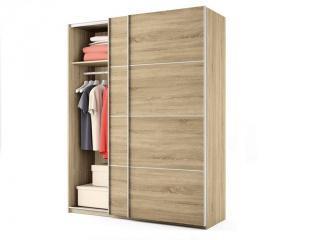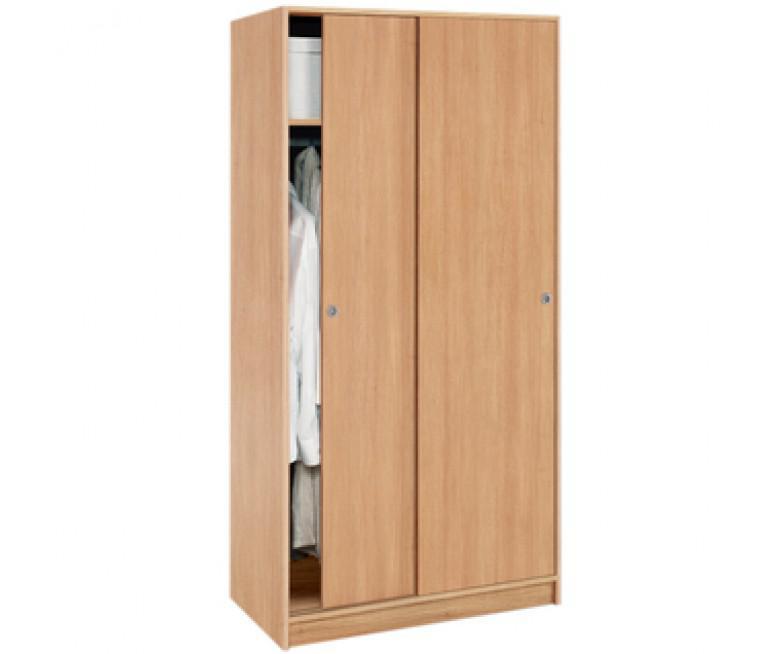The first image is the image on the left, the second image is the image on the right. Considering the images on both sides, is "The closet in the image on the left is partially open." valid? Answer yes or no. Yes. 